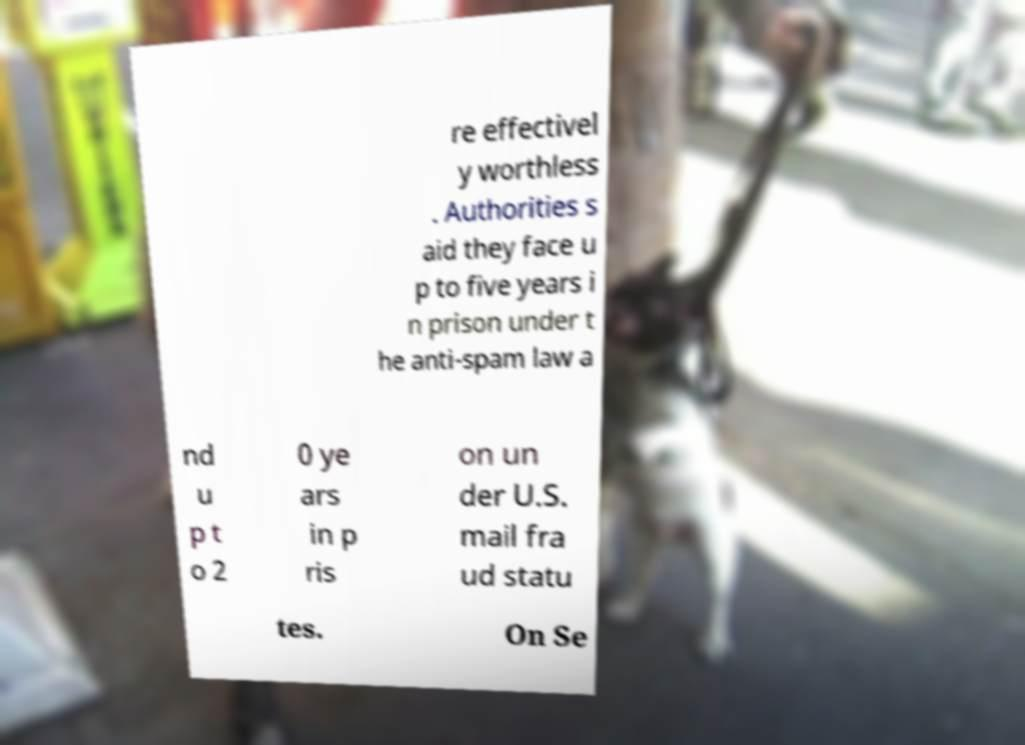For documentation purposes, I need the text within this image transcribed. Could you provide that? re effectivel y worthless . Authorities s aid they face u p to five years i n prison under t he anti-spam law a nd u p t o 2 0 ye ars in p ris on un der U.S. mail fra ud statu tes. On Se 